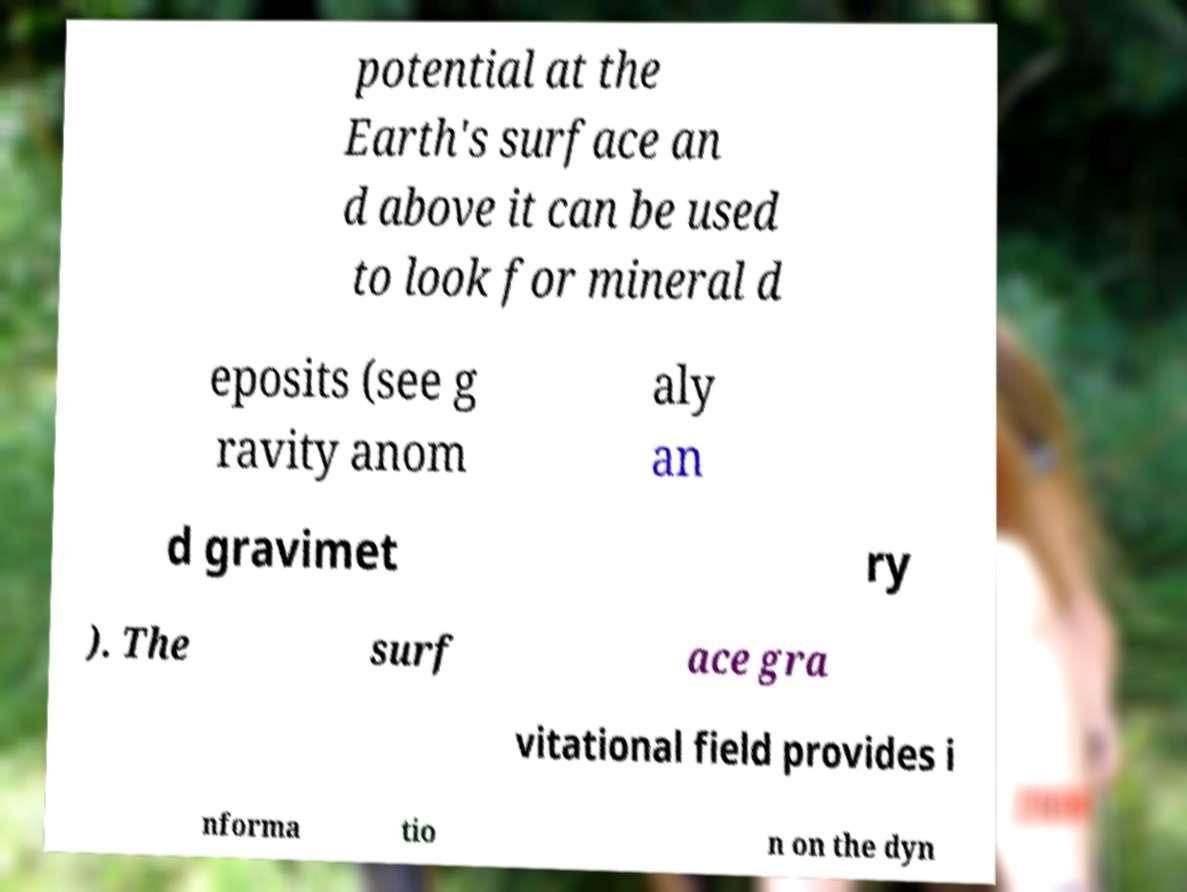Could you extract and type out the text from this image? potential at the Earth's surface an d above it can be used to look for mineral d eposits (see g ravity anom aly an d gravimet ry ). The surf ace gra vitational field provides i nforma tio n on the dyn 